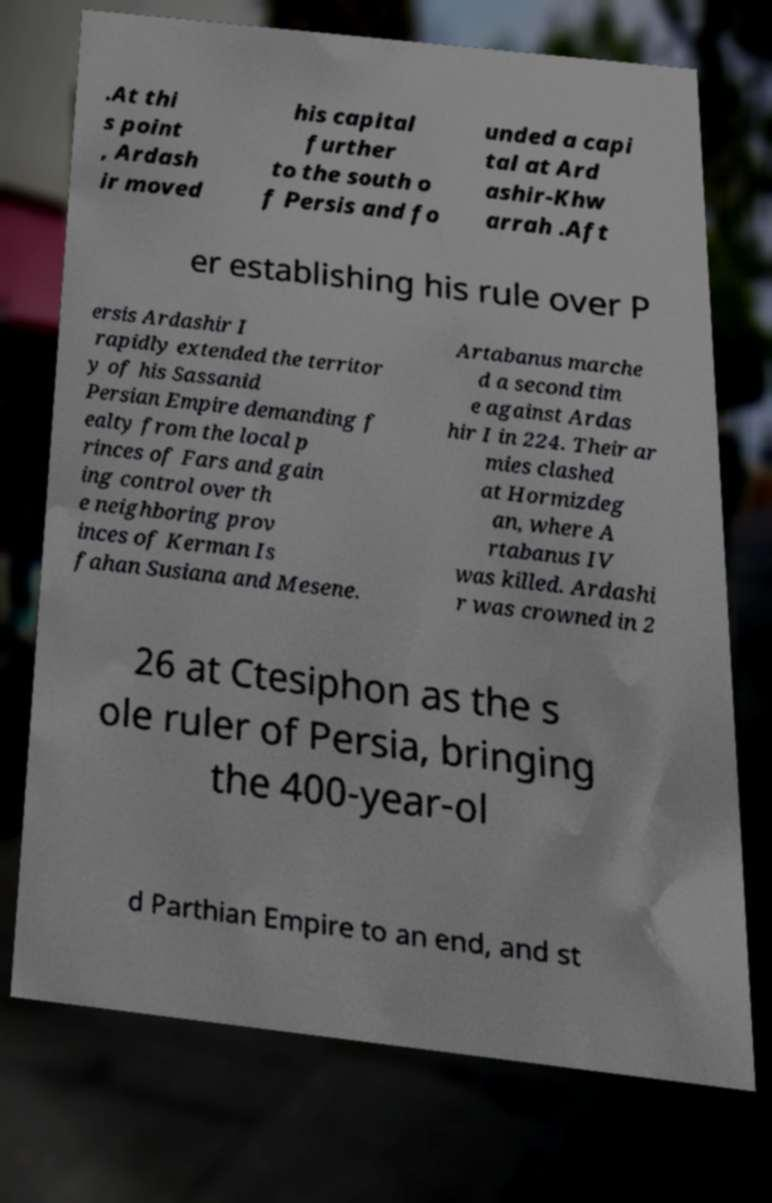For documentation purposes, I need the text within this image transcribed. Could you provide that? .At thi s point , Ardash ir moved his capital further to the south o f Persis and fo unded a capi tal at Ard ashir-Khw arrah .Aft er establishing his rule over P ersis Ardashir I rapidly extended the territor y of his Sassanid Persian Empire demanding f ealty from the local p rinces of Fars and gain ing control over th e neighboring prov inces of Kerman Is fahan Susiana and Mesene. Artabanus marche d a second tim e against Ardas hir I in 224. Their ar mies clashed at Hormizdeg an, where A rtabanus IV was killed. Ardashi r was crowned in 2 26 at Ctesiphon as the s ole ruler of Persia, bringing the 400-year-ol d Parthian Empire to an end, and st 